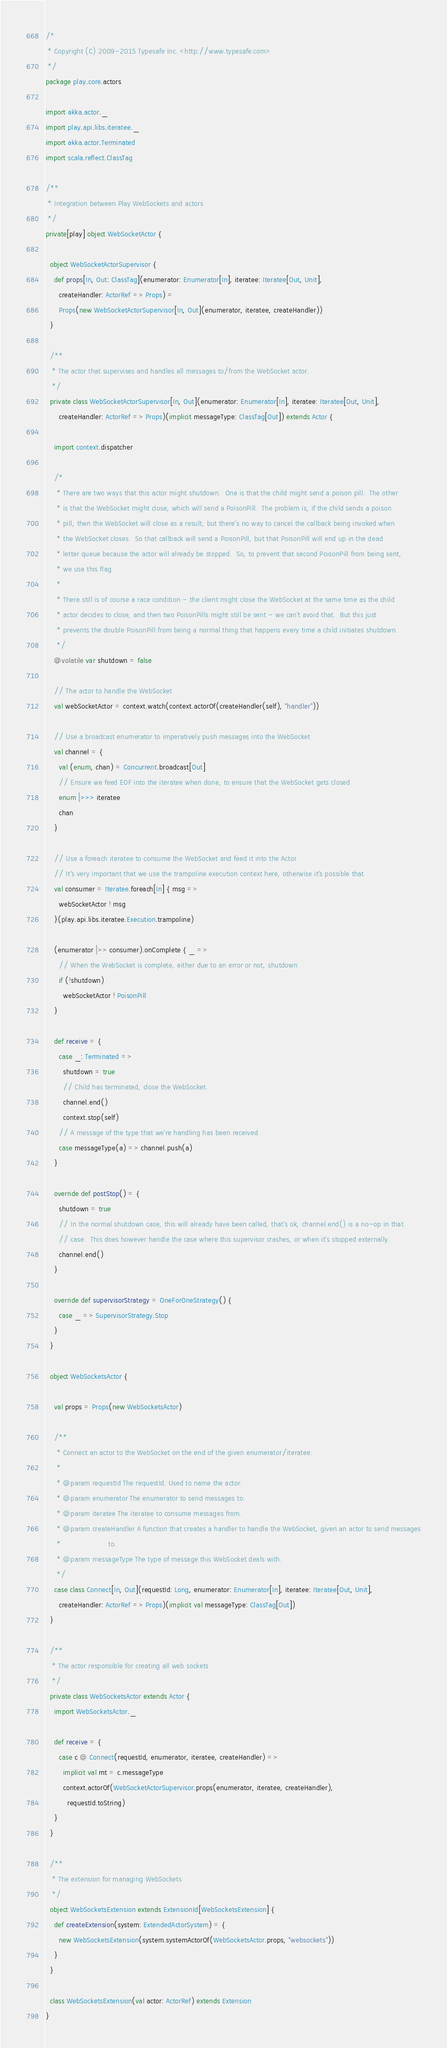Convert code to text. <code><loc_0><loc_0><loc_500><loc_500><_Scala_>/*
 * Copyright (C) 2009-2015 Typesafe Inc. <http://www.typesafe.com>
 */
package play.core.actors

import akka.actor._
import play.api.libs.iteratee._
import akka.actor.Terminated
import scala.reflect.ClassTag

/**
 * Integration between Play WebSockets and actors
 */
private[play] object WebSocketActor {

  object WebSocketActorSupervisor {
    def props[In, Out: ClassTag](enumerator: Enumerator[In], iteratee: Iteratee[Out, Unit],
      createHandler: ActorRef => Props) =
      Props(new WebSocketActorSupervisor[In, Out](enumerator, iteratee, createHandler))
  }

  /**
   * The actor that supervises and handles all messages to/from the WebSocket actor.
   */
  private class WebSocketActorSupervisor[In, Out](enumerator: Enumerator[In], iteratee: Iteratee[Out, Unit],
      createHandler: ActorRef => Props)(implicit messageType: ClassTag[Out]) extends Actor {

    import context.dispatcher

    /*
     * There are two ways that this actor might shutdown.  One is that the child might send a poison pill.  The other
     * is that the WebSocket might close, which will send a PoisonPill.  The problem is, if the child sends a poison
     * pill, then the WebSocket will close as a result, but there's no way to cancel the callback being invoked when
     * the WebSocket closes.  So that callback will send a PoisonPill, but that PoisonPill will end up in the dead
     * letter queue because the actor will already be stopped.  So, to prevent that second PoisonPill from being sent,
     * we use this flag.
     *
     * There still is of course a race condition - the client might close the WebSocket at the same time as the child
     * actor decides to close, and then two PoisonPills might still be sent - we can't avoid that.  But this just
     * prevents the double PoisonPill from being a normal thing that happens every time a child initiates shutdown.
     */
    @volatile var shutdown = false

    // The actor to handle the WebSocket
    val webSocketActor = context.watch(context.actorOf(createHandler(self), "handler"))

    // Use a broadcast enumerator to imperatively push messages into the WebSocket
    val channel = {
      val (enum, chan) = Concurrent.broadcast[Out]
      // Ensure we feed EOF into the iteratee when done, to ensure that the WebSocket gets closed
      enum |>>> iteratee
      chan
    }

    // Use a foreach iteratee to consume the WebSocket and feed it into the Actor
    // It's very important that we use the trampoline execution context here, otherwise it's possible that
    val consumer = Iteratee.foreach[In] { msg =>
      webSocketActor ! msg
    }(play.api.libs.iteratee.Execution.trampoline)

    (enumerator |>> consumer).onComplete { _ =>
      // When the WebSocket is complete, either due to an error or not, shutdown
      if (!shutdown)
        webSocketActor ! PoisonPill
    }

    def receive = {
      case _: Terminated =>
        shutdown = true
        // Child has terminated, close the WebSocket.
        channel.end()
        context.stop(self)
      // A message of the type that we're handling has been received
      case messageType(a) => channel.push(a)
    }

    override def postStop() = {
      shutdown = true
      // In the normal shutdown case, this will already have been called, that's ok, channel.end() is a no-op in that
      // case.  This does however handle the case where this supervisor crashes, or when it's stopped externally.
      channel.end()
    }

    override def supervisorStrategy = OneForOneStrategy() {
      case _ => SupervisorStrategy.Stop
    }
  }

  object WebSocketsActor {

    val props = Props(new WebSocketsActor)

    /**
     * Connect an actor to the WebSocket on the end of the given enumerator/iteratee.
     *
     * @param requestId The requestId. Used to name the actor.
     * @param enumerator The enumerator to send messages to.
     * @param iteratee The iteratee to consume messages from.
     * @param createHandler A function that creates a handler to handle the WebSocket, given an actor to send messages
     *                      to.
     * @param messageType The type of message this WebSocket deals with.
     */
    case class Connect[In, Out](requestId: Long, enumerator: Enumerator[In], iteratee: Iteratee[Out, Unit],
      createHandler: ActorRef => Props)(implicit val messageType: ClassTag[Out])
  }

  /**
   * The actor responsible for creating all web sockets
   */
  private class WebSocketsActor extends Actor {
    import WebSocketsActor._

    def receive = {
      case c @ Connect(requestId, enumerator, iteratee, createHandler) =>
        implicit val mt = c.messageType
        context.actorOf(WebSocketActorSupervisor.props(enumerator, iteratee, createHandler),
          requestId.toString)
    }
  }

  /**
   * The extension for managing WebSockets
   */
  object WebSocketsExtension extends ExtensionId[WebSocketsExtension] {
    def createExtension(system: ExtendedActorSystem) = {
      new WebSocketsExtension(system.systemActorOf(WebSocketsActor.props, "websockets"))
    }
  }

  class WebSocketsExtension(val actor: ActorRef) extends Extension
}
</code> 